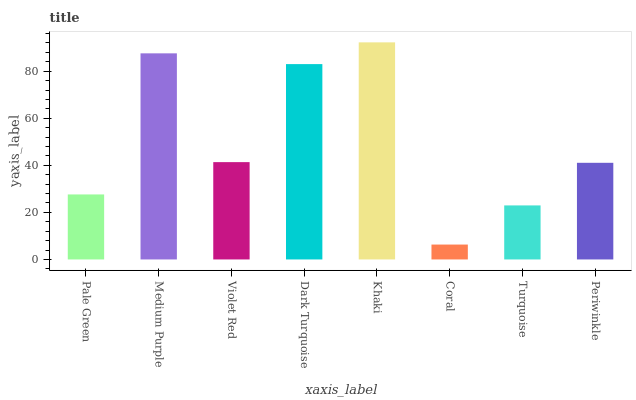Is Coral the minimum?
Answer yes or no. Yes. Is Khaki the maximum?
Answer yes or no. Yes. Is Medium Purple the minimum?
Answer yes or no. No. Is Medium Purple the maximum?
Answer yes or no. No. Is Medium Purple greater than Pale Green?
Answer yes or no. Yes. Is Pale Green less than Medium Purple?
Answer yes or no. Yes. Is Pale Green greater than Medium Purple?
Answer yes or no. No. Is Medium Purple less than Pale Green?
Answer yes or no. No. Is Violet Red the high median?
Answer yes or no. Yes. Is Periwinkle the low median?
Answer yes or no. Yes. Is Medium Purple the high median?
Answer yes or no. No. Is Violet Red the low median?
Answer yes or no. No. 